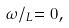<formula> <loc_0><loc_0><loc_500><loc_500>\omega / _ { L } = 0 ,</formula> 